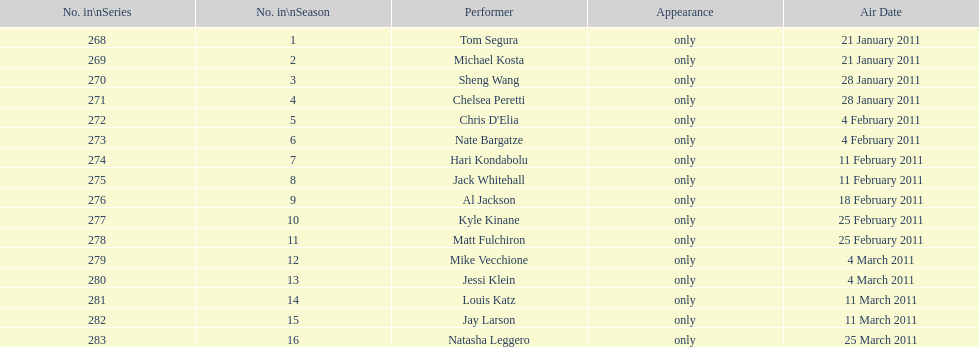How many different performers appeared during this season? 16. 